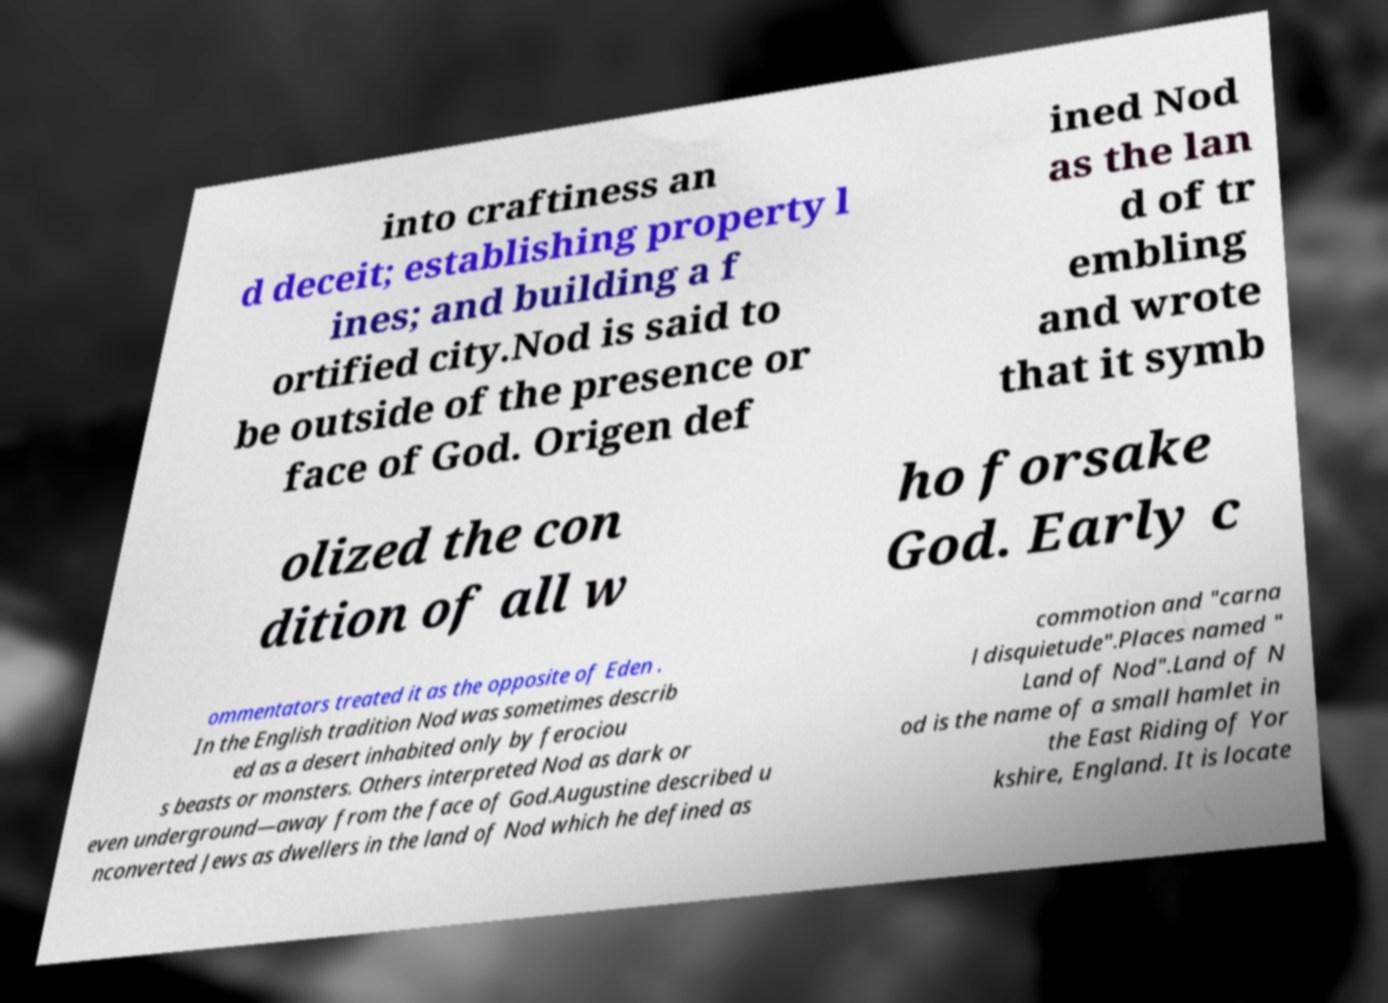Could you assist in decoding the text presented in this image and type it out clearly? into craftiness an d deceit; establishing property l ines; and building a f ortified city.Nod is said to be outside of the presence or face of God. Origen def ined Nod as the lan d of tr embling and wrote that it symb olized the con dition of all w ho forsake God. Early c ommentators treated it as the opposite of Eden . In the English tradition Nod was sometimes describ ed as a desert inhabited only by ferociou s beasts or monsters. Others interpreted Nod as dark or even underground—away from the face of God.Augustine described u nconverted Jews as dwellers in the land of Nod which he defined as commotion and "carna l disquietude".Places named " Land of Nod".Land of N od is the name of a small hamlet in the East Riding of Yor kshire, England. It is locate 